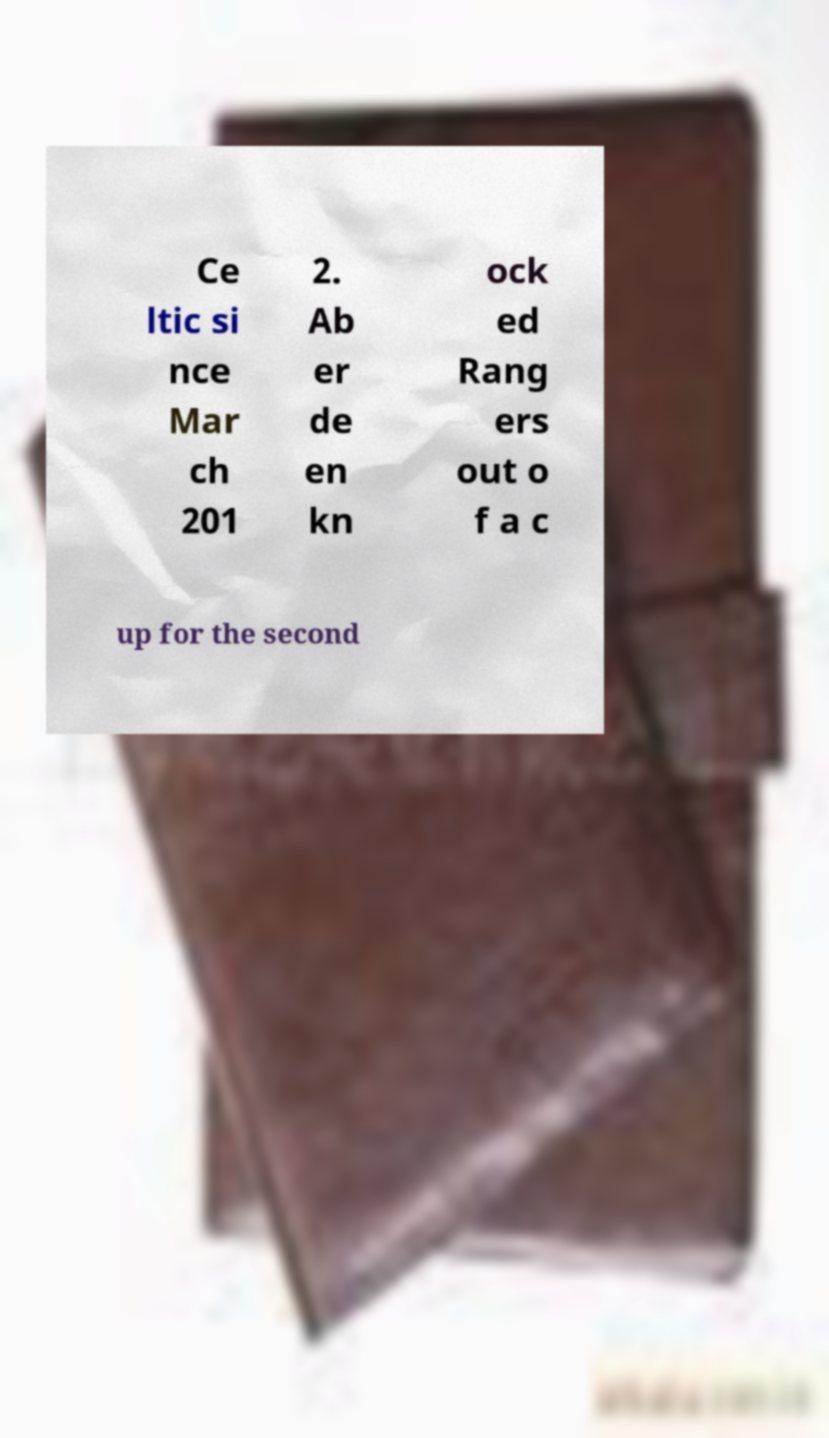I need the written content from this picture converted into text. Can you do that? Ce ltic si nce Mar ch 201 2. Ab er de en kn ock ed Rang ers out o f a c up for the second 